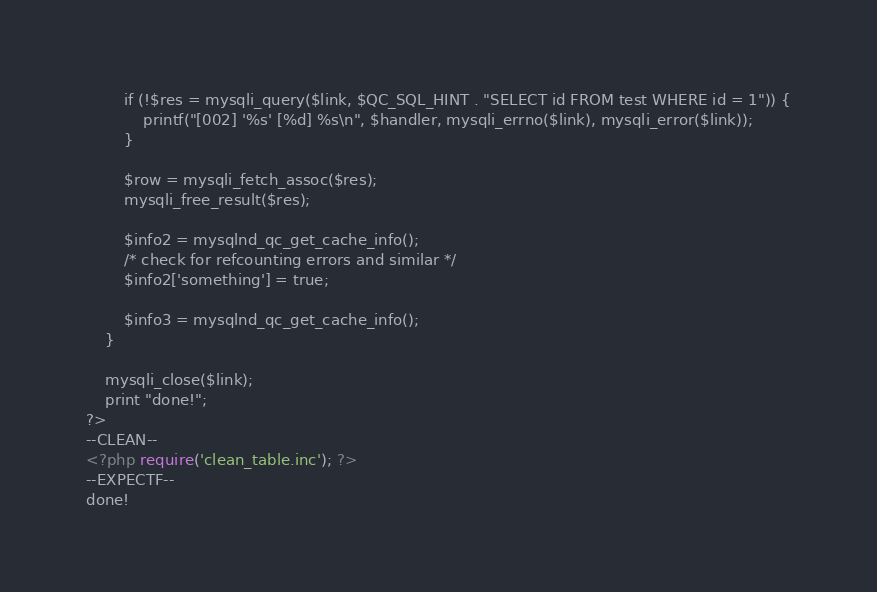Convert code to text. <code><loc_0><loc_0><loc_500><loc_500><_PHP_>		if (!$res = mysqli_query($link, $QC_SQL_HINT . "SELECT id FROM test WHERE id = 1")) {
			printf("[002] '%s' [%d] %s\n", $handler, mysqli_errno($link), mysqli_error($link));
		}

		$row = mysqli_fetch_assoc($res);
		mysqli_free_result($res);

		$info2 = mysqlnd_qc_get_cache_info();
		/* check for refcounting errors and similar */
		$info2['something'] = true;

		$info3 = mysqlnd_qc_get_cache_info();
	}

	mysqli_close($link);
	print "done!";
?>
--CLEAN--
<?php require('clean_table.inc'); ?>
--EXPECTF--
done!</code> 